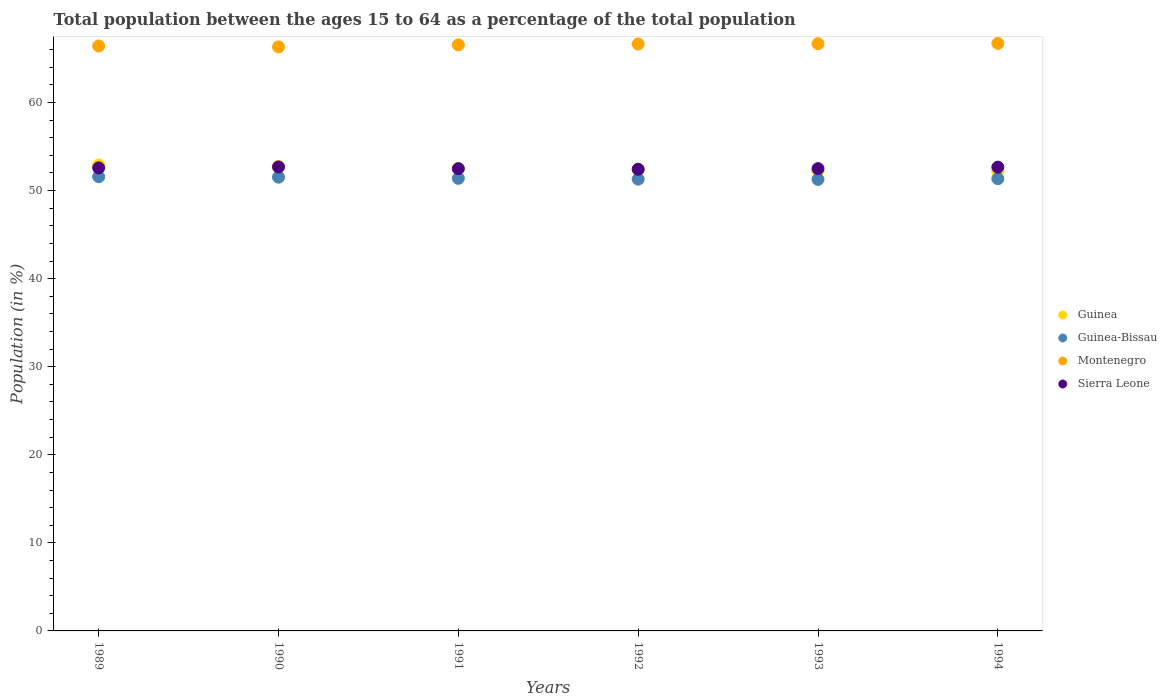How many different coloured dotlines are there?
Your response must be concise. 4. What is the percentage of the population ages 15 to 64 in Guinea in 1991?
Your answer should be very brief. 52.51. Across all years, what is the maximum percentage of the population ages 15 to 64 in Guinea-Bissau?
Give a very brief answer. 51.57. Across all years, what is the minimum percentage of the population ages 15 to 64 in Guinea-Bissau?
Offer a terse response. 51.27. In which year was the percentage of the population ages 15 to 64 in Sierra Leone minimum?
Ensure brevity in your answer.  1992. What is the total percentage of the population ages 15 to 64 in Guinea in the graph?
Offer a very short reply. 314.95. What is the difference between the percentage of the population ages 15 to 64 in Montenegro in 1991 and that in 1992?
Make the answer very short. -0.1. What is the difference between the percentage of the population ages 15 to 64 in Guinea-Bissau in 1991 and the percentage of the population ages 15 to 64 in Sierra Leone in 1990?
Ensure brevity in your answer.  -1.3. What is the average percentage of the population ages 15 to 64 in Sierra Leone per year?
Offer a very short reply. 52.55. In the year 1994, what is the difference between the percentage of the population ages 15 to 64 in Montenegro and percentage of the population ages 15 to 64 in Sierra Leone?
Provide a succinct answer. 14.05. What is the ratio of the percentage of the population ages 15 to 64 in Guinea in 1989 to that in 1994?
Provide a short and direct response. 1.01. What is the difference between the highest and the second highest percentage of the population ages 15 to 64 in Sierra Leone?
Your response must be concise. 0.02. What is the difference between the highest and the lowest percentage of the population ages 15 to 64 in Guinea-Bissau?
Your answer should be very brief. 0.3. Is the sum of the percentage of the population ages 15 to 64 in Guinea-Bissau in 1989 and 1991 greater than the maximum percentage of the population ages 15 to 64 in Sierra Leone across all years?
Provide a short and direct response. Yes. Is it the case that in every year, the sum of the percentage of the population ages 15 to 64 in Montenegro and percentage of the population ages 15 to 64 in Sierra Leone  is greater than the sum of percentage of the population ages 15 to 64 in Guinea-Bissau and percentage of the population ages 15 to 64 in Guinea?
Provide a succinct answer. Yes. Does the percentage of the population ages 15 to 64 in Montenegro monotonically increase over the years?
Offer a very short reply. No. Is the percentage of the population ages 15 to 64 in Guinea strictly greater than the percentage of the population ages 15 to 64 in Guinea-Bissau over the years?
Your response must be concise. Yes. How many dotlines are there?
Offer a very short reply. 4. Are the values on the major ticks of Y-axis written in scientific E-notation?
Make the answer very short. No. Does the graph contain any zero values?
Your answer should be compact. No. Where does the legend appear in the graph?
Your answer should be compact. Center right. How are the legend labels stacked?
Ensure brevity in your answer.  Vertical. What is the title of the graph?
Your answer should be compact. Total population between the ages 15 to 64 as a percentage of the total population. Does "Brunei Darussalam" appear as one of the legend labels in the graph?
Keep it short and to the point. No. What is the label or title of the X-axis?
Keep it short and to the point. Years. What is the Population (in %) of Guinea in 1989?
Provide a short and direct response. 52.91. What is the Population (in %) in Guinea-Bissau in 1989?
Give a very brief answer. 51.57. What is the Population (in %) in Montenegro in 1989?
Give a very brief answer. 66.42. What is the Population (in %) in Sierra Leone in 1989?
Give a very brief answer. 52.58. What is the Population (in %) in Guinea in 1990?
Keep it short and to the point. 52.74. What is the Population (in %) of Guinea-Bissau in 1990?
Offer a terse response. 51.52. What is the Population (in %) of Montenegro in 1990?
Give a very brief answer. 66.32. What is the Population (in %) in Sierra Leone in 1990?
Ensure brevity in your answer.  52.68. What is the Population (in %) of Guinea in 1991?
Offer a very short reply. 52.51. What is the Population (in %) in Guinea-Bissau in 1991?
Make the answer very short. 51.39. What is the Population (in %) of Montenegro in 1991?
Your answer should be very brief. 66.54. What is the Population (in %) in Sierra Leone in 1991?
Keep it short and to the point. 52.49. What is the Population (in %) of Guinea in 1992?
Keep it short and to the point. 52.35. What is the Population (in %) in Guinea-Bissau in 1992?
Provide a short and direct response. 51.3. What is the Population (in %) in Montenegro in 1992?
Your answer should be compact. 66.65. What is the Population (in %) of Sierra Leone in 1992?
Make the answer very short. 52.42. What is the Population (in %) in Guinea in 1993?
Offer a terse response. 52.24. What is the Population (in %) in Guinea-Bissau in 1993?
Provide a short and direct response. 51.27. What is the Population (in %) in Montenegro in 1993?
Make the answer very short. 66.68. What is the Population (in %) in Sierra Leone in 1993?
Provide a succinct answer. 52.49. What is the Population (in %) in Guinea in 1994?
Make the answer very short. 52.2. What is the Population (in %) in Guinea-Bissau in 1994?
Your answer should be compact. 51.35. What is the Population (in %) of Montenegro in 1994?
Make the answer very short. 66.71. What is the Population (in %) in Sierra Leone in 1994?
Provide a succinct answer. 52.66. Across all years, what is the maximum Population (in %) of Guinea?
Give a very brief answer. 52.91. Across all years, what is the maximum Population (in %) of Guinea-Bissau?
Give a very brief answer. 51.57. Across all years, what is the maximum Population (in %) in Montenegro?
Keep it short and to the point. 66.71. Across all years, what is the maximum Population (in %) of Sierra Leone?
Provide a succinct answer. 52.68. Across all years, what is the minimum Population (in %) of Guinea?
Offer a very short reply. 52.2. Across all years, what is the minimum Population (in %) of Guinea-Bissau?
Offer a terse response. 51.27. Across all years, what is the minimum Population (in %) in Montenegro?
Provide a succinct answer. 66.32. Across all years, what is the minimum Population (in %) in Sierra Leone?
Your answer should be very brief. 52.42. What is the total Population (in %) of Guinea in the graph?
Make the answer very short. 314.95. What is the total Population (in %) of Guinea-Bissau in the graph?
Keep it short and to the point. 308.39. What is the total Population (in %) in Montenegro in the graph?
Your answer should be compact. 399.31. What is the total Population (in %) of Sierra Leone in the graph?
Make the answer very short. 315.32. What is the difference between the Population (in %) in Guinea in 1989 and that in 1990?
Offer a very short reply. 0.17. What is the difference between the Population (in %) in Guinea-Bissau in 1989 and that in 1990?
Ensure brevity in your answer.  0.05. What is the difference between the Population (in %) in Sierra Leone in 1989 and that in 1990?
Offer a terse response. -0.11. What is the difference between the Population (in %) in Guinea in 1989 and that in 1991?
Your answer should be compact. 0.39. What is the difference between the Population (in %) in Guinea-Bissau in 1989 and that in 1991?
Make the answer very short. 0.18. What is the difference between the Population (in %) in Montenegro in 1989 and that in 1991?
Make the answer very short. -0.13. What is the difference between the Population (in %) of Sierra Leone in 1989 and that in 1991?
Ensure brevity in your answer.  0.09. What is the difference between the Population (in %) of Guinea in 1989 and that in 1992?
Offer a terse response. 0.55. What is the difference between the Population (in %) in Guinea-Bissau in 1989 and that in 1992?
Offer a terse response. 0.28. What is the difference between the Population (in %) of Montenegro in 1989 and that in 1992?
Provide a short and direct response. -0.23. What is the difference between the Population (in %) of Sierra Leone in 1989 and that in 1992?
Provide a short and direct response. 0.16. What is the difference between the Population (in %) in Guinea in 1989 and that in 1993?
Your response must be concise. 0.67. What is the difference between the Population (in %) of Guinea-Bissau in 1989 and that in 1993?
Keep it short and to the point. 0.3. What is the difference between the Population (in %) in Montenegro in 1989 and that in 1993?
Provide a short and direct response. -0.26. What is the difference between the Population (in %) in Sierra Leone in 1989 and that in 1993?
Ensure brevity in your answer.  0.09. What is the difference between the Population (in %) of Guinea in 1989 and that in 1994?
Ensure brevity in your answer.  0.71. What is the difference between the Population (in %) in Guinea-Bissau in 1989 and that in 1994?
Ensure brevity in your answer.  0.22. What is the difference between the Population (in %) of Montenegro in 1989 and that in 1994?
Your response must be concise. -0.3. What is the difference between the Population (in %) of Sierra Leone in 1989 and that in 1994?
Provide a short and direct response. -0.08. What is the difference between the Population (in %) of Guinea in 1990 and that in 1991?
Offer a terse response. 0.22. What is the difference between the Population (in %) in Guinea-Bissau in 1990 and that in 1991?
Your response must be concise. 0.13. What is the difference between the Population (in %) of Montenegro in 1990 and that in 1991?
Offer a terse response. -0.23. What is the difference between the Population (in %) of Sierra Leone in 1990 and that in 1991?
Your response must be concise. 0.2. What is the difference between the Population (in %) of Guinea in 1990 and that in 1992?
Offer a terse response. 0.39. What is the difference between the Population (in %) of Guinea-Bissau in 1990 and that in 1992?
Make the answer very short. 0.22. What is the difference between the Population (in %) in Montenegro in 1990 and that in 1992?
Your response must be concise. -0.33. What is the difference between the Population (in %) of Sierra Leone in 1990 and that in 1992?
Your answer should be compact. 0.26. What is the difference between the Population (in %) of Guinea in 1990 and that in 1993?
Your answer should be very brief. 0.5. What is the difference between the Population (in %) in Guinea-Bissau in 1990 and that in 1993?
Offer a terse response. 0.25. What is the difference between the Population (in %) of Montenegro in 1990 and that in 1993?
Your response must be concise. -0.36. What is the difference between the Population (in %) of Sierra Leone in 1990 and that in 1993?
Provide a short and direct response. 0.19. What is the difference between the Population (in %) in Guinea in 1990 and that in 1994?
Keep it short and to the point. 0.54. What is the difference between the Population (in %) in Guinea-Bissau in 1990 and that in 1994?
Make the answer very short. 0.17. What is the difference between the Population (in %) in Montenegro in 1990 and that in 1994?
Provide a succinct answer. -0.4. What is the difference between the Population (in %) in Sierra Leone in 1990 and that in 1994?
Offer a very short reply. 0.02. What is the difference between the Population (in %) of Guinea in 1991 and that in 1992?
Your response must be concise. 0.16. What is the difference between the Population (in %) of Guinea-Bissau in 1991 and that in 1992?
Keep it short and to the point. 0.09. What is the difference between the Population (in %) of Montenegro in 1991 and that in 1992?
Provide a short and direct response. -0.1. What is the difference between the Population (in %) in Sierra Leone in 1991 and that in 1992?
Offer a terse response. 0.07. What is the difference between the Population (in %) of Guinea in 1991 and that in 1993?
Your answer should be very brief. 0.28. What is the difference between the Population (in %) of Guinea-Bissau in 1991 and that in 1993?
Your answer should be compact. 0.12. What is the difference between the Population (in %) of Montenegro in 1991 and that in 1993?
Make the answer very short. -0.14. What is the difference between the Population (in %) of Sierra Leone in 1991 and that in 1993?
Offer a very short reply. -0.01. What is the difference between the Population (in %) in Guinea in 1991 and that in 1994?
Provide a succinct answer. 0.31. What is the difference between the Population (in %) in Guinea-Bissau in 1991 and that in 1994?
Offer a very short reply. 0.04. What is the difference between the Population (in %) of Montenegro in 1991 and that in 1994?
Ensure brevity in your answer.  -0.17. What is the difference between the Population (in %) of Sierra Leone in 1991 and that in 1994?
Your response must be concise. -0.17. What is the difference between the Population (in %) of Guinea in 1992 and that in 1993?
Provide a short and direct response. 0.12. What is the difference between the Population (in %) in Guinea-Bissau in 1992 and that in 1993?
Offer a terse response. 0.03. What is the difference between the Population (in %) in Montenegro in 1992 and that in 1993?
Keep it short and to the point. -0.03. What is the difference between the Population (in %) in Sierra Leone in 1992 and that in 1993?
Your answer should be very brief. -0.07. What is the difference between the Population (in %) in Guinea in 1992 and that in 1994?
Give a very brief answer. 0.15. What is the difference between the Population (in %) in Guinea-Bissau in 1992 and that in 1994?
Provide a short and direct response. -0.05. What is the difference between the Population (in %) of Montenegro in 1992 and that in 1994?
Provide a succinct answer. -0.07. What is the difference between the Population (in %) of Sierra Leone in 1992 and that in 1994?
Keep it short and to the point. -0.24. What is the difference between the Population (in %) in Guinea in 1993 and that in 1994?
Provide a succinct answer. 0.04. What is the difference between the Population (in %) of Guinea-Bissau in 1993 and that in 1994?
Make the answer very short. -0.08. What is the difference between the Population (in %) of Montenegro in 1993 and that in 1994?
Your answer should be compact. -0.03. What is the difference between the Population (in %) in Sierra Leone in 1993 and that in 1994?
Your answer should be compact. -0.17. What is the difference between the Population (in %) in Guinea in 1989 and the Population (in %) in Guinea-Bissau in 1990?
Give a very brief answer. 1.39. What is the difference between the Population (in %) in Guinea in 1989 and the Population (in %) in Montenegro in 1990?
Make the answer very short. -13.41. What is the difference between the Population (in %) of Guinea in 1989 and the Population (in %) of Sierra Leone in 1990?
Offer a very short reply. 0.22. What is the difference between the Population (in %) in Guinea-Bissau in 1989 and the Population (in %) in Montenegro in 1990?
Give a very brief answer. -14.74. What is the difference between the Population (in %) in Guinea-Bissau in 1989 and the Population (in %) in Sierra Leone in 1990?
Keep it short and to the point. -1.11. What is the difference between the Population (in %) in Montenegro in 1989 and the Population (in %) in Sierra Leone in 1990?
Give a very brief answer. 13.73. What is the difference between the Population (in %) in Guinea in 1989 and the Population (in %) in Guinea-Bissau in 1991?
Your answer should be compact. 1.52. What is the difference between the Population (in %) of Guinea in 1989 and the Population (in %) of Montenegro in 1991?
Offer a very short reply. -13.64. What is the difference between the Population (in %) in Guinea in 1989 and the Population (in %) in Sierra Leone in 1991?
Offer a very short reply. 0.42. What is the difference between the Population (in %) of Guinea-Bissau in 1989 and the Population (in %) of Montenegro in 1991?
Offer a terse response. -14.97. What is the difference between the Population (in %) of Guinea-Bissau in 1989 and the Population (in %) of Sierra Leone in 1991?
Your answer should be very brief. -0.91. What is the difference between the Population (in %) in Montenegro in 1989 and the Population (in %) in Sierra Leone in 1991?
Provide a succinct answer. 13.93. What is the difference between the Population (in %) in Guinea in 1989 and the Population (in %) in Guinea-Bissau in 1992?
Offer a very short reply. 1.61. What is the difference between the Population (in %) in Guinea in 1989 and the Population (in %) in Montenegro in 1992?
Your response must be concise. -13.74. What is the difference between the Population (in %) in Guinea in 1989 and the Population (in %) in Sierra Leone in 1992?
Offer a very short reply. 0.49. What is the difference between the Population (in %) of Guinea-Bissau in 1989 and the Population (in %) of Montenegro in 1992?
Offer a very short reply. -15.07. What is the difference between the Population (in %) in Guinea-Bissau in 1989 and the Population (in %) in Sierra Leone in 1992?
Offer a terse response. -0.85. What is the difference between the Population (in %) of Montenegro in 1989 and the Population (in %) of Sierra Leone in 1992?
Ensure brevity in your answer.  14. What is the difference between the Population (in %) in Guinea in 1989 and the Population (in %) in Guinea-Bissau in 1993?
Offer a very short reply. 1.64. What is the difference between the Population (in %) in Guinea in 1989 and the Population (in %) in Montenegro in 1993?
Provide a short and direct response. -13.77. What is the difference between the Population (in %) in Guinea in 1989 and the Population (in %) in Sierra Leone in 1993?
Give a very brief answer. 0.41. What is the difference between the Population (in %) of Guinea-Bissau in 1989 and the Population (in %) of Montenegro in 1993?
Your answer should be compact. -15.11. What is the difference between the Population (in %) in Guinea-Bissau in 1989 and the Population (in %) in Sierra Leone in 1993?
Offer a terse response. -0.92. What is the difference between the Population (in %) of Montenegro in 1989 and the Population (in %) of Sierra Leone in 1993?
Make the answer very short. 13.92. What is the difference between the Population (in %) in Guinea in 1989 and the Population (in %) in Guinea-Bissau in 1994?
Provide a succinct answer. 1.56. What is the difference between the Population (in %) of Guinea in 1989 and the Population (in %) of Montenegro in 1994?
Give a very brief answer. -13.81. What is the difference between the Population (in %) of Guinea in 1989 and the Population (in %) of Sierra Leone in 1994?
Provide a short and direct response. 0.25. What is the difference between the Population (in %) of Guinea-Bissau in 1989 and the Population (in %) of Montenegro in 1994?
Offer a very short reply. -15.14. What is the difference between the Population (in %) of Guinea-Bissau in 1989 and the Population (in %) of Sierra Leone in 1994?
Give a very brief answer. -1.09. What is the difference between the Population (in %) of Montenegro in 1989 and the Population (in %) of Sierra Leone in 1994?
Provide a succinct answer. 13.76. What is the difference between the Population (in %) in Guinea in 1990 and the Population (in %) in Guinea-Bissau in 1991?
Provide a short and direct response. 1.35. What is the difference between the Population (in %) of Guinea in 1990 and the Population (in %) of Montenegro in 1991?
Offer a terse response. -13.8. What is the difference between the Population (in %) of Guinea in 1990 and the Population (in %) of Sierra Leone in 1991?
Your response must be concise. 0.25. What is the difference between the Population (in %) of Guinea-Bissau in 1990 and the Population (in %) of Montenegro in 1991?
Provide a short and direct response. -15.02. What is the difference between the Population (in %) in Guinea-Bissau in 1990 and the Population (in %) in Sierra Leone in 1991?
Make the answer very short. -0.97. What is the difference between the Population (in %) in Montenegro in 1990 and the Population (in %) in Sierra Leone in 1991?
Offer a very short reply. 13.83. What is the difference between the Population (in %) of Guinea in 1990 and the Population (in %) of Guinea-Bissau in 1992?
Provide a short and direct response. 1.44. What is the difference between the Population (in %) of Guinea in 1990 and the Population (in %) of Montenegro in 1992?
Provide a short and direct response. -13.91. What is the difference between the Population (in %) in Guinea in 1990 and the Population (in %) in Sierra Leone in 1992?
Your answer should be compact. 0.32. What is the difference between the Population (in %) in Guinea-Bissau in 1990 and the Population (in %) in Montenegro in 1992?
Provide a short and direct response. -15.13. What is the difference between the Population (in %) of Guinea-Bissau in 1990 and the Population (in %) of Sierra Leone in 1992?
Give a very brief answer. -0.9. What is the difference between the Population (in %) in Montenegro in 1990 and the Population (in %) in Sierra Leone in 1992?
Your answer should be very brief. 13.9. What is the difference between the Population (in %) in Guinea in 1990 and the Population (in %) in Guinea-Bissau in 1993?
Your response must be concise. 1.47. What is the difference between the Population (in %) in Guinea in 1990 and the Population (in %) in Montenegro in 1993?
Make the answer very short. -13.94. What is the difference between the Population (in %) in Guinea in 1990 and the Population (in %) in Sierra Leone in 1993?
Your answer should be compact. 0.25. What is the difference between the Population (in %) of Guinea-Bissau in 1990 and the Population (in %) of Montenegro in 1993?
Your answer should be compact. -15.16. What is the difference between the Population (in %) of Guinea-Bissau in 1990 and the Population (in %) of Sierra Leone in 1993?
Give a very brief answer. -0.97. What is the difference between the Population (in %) of Montenegro in 1990 and the Population (in %) of Sierra Leone in 1993?
Offer a terse response. 13.82. What is the difference between the Population (in %) in Guinea in 1990 and the Population (in %) in Guinea-Bissau in 1994?
Provide a succinct answer. 1.39. What is the difference between the Population (in %) in Guinea in 1990 and the Population (in %) in Montenegro in 1994?
Make the answer very short. -13.98. What is the difference between the Population (in %) in Guinea in 1990 and the Population (in %) in Sierra Leone in 1994?
Your answer should be compact. 0.08. What is the difference between the Population (in %) in Guinea-Bissau in 1990 and the Population (in %) in Montenegro in 1994?
Provide a short and direct response. -15.19. What is the difference between the Population (in %) of Guinea-Bissau in 1990 and the Population (in %) of Sierra Leone in 1994?
Offer a terse response. -1.14. What is the difference between the Population (in %) of Montenegro in 1990 and the Population (in %) of Sierra Leone in 1994?
Keep it short and to the point. 13.66. What is the difference between the Population (in %) of Guinea in 1991 and the Population (in %) of Guinea-Bissau in 1992?
Your response must be concise. 1.22. What is the difference between the Population (in %) of Guinea in 1991 and the Population (in %) of Montenegro in 1992?
Offer a very short reply. -14.13. What is the difference between the Population (in %) in Guinea in 1991 and the Population (in %) in Sierra Leone in 1992?
Keep it short and to the point. 0.09. What is the difference between the Population (in %) in Guinea-Bissau in 1991 and the Population (in %) in Montenegro in 1992?
Make the answer very short. -15.26. What is the difference between the Population (in %) in Guinea-Bissau in 1991 and the Population (in %) in Sierra Leone in 1992?
Give a very brief answer. -1.03. What is the difference between the Population (in %) in Montenegro in 1991 and the Population (in %) in Sierra Leone in 1992?
Keep it short and to the point. 14.12. What is the difference between the Population (in %) in Guinea in 1991 and the Population (in %) in Guinea-Bissau in 1993?
Offer a very short reply. 1.24. What is the difference between the Population (in %) in Guinea in 1991 and the Population (in %) in Montenegro in 1993?
Offer a terse response. -14.17. What is the difference between the Population (in %) in Guinea in 1991 and the Population (in %) in Sierra Leone in 1993?
Make the answer very short. 0.02. What is the difference between the Population (in %) of Guinea-Bissau in 1991 and the Population (in %) of Montenegro in 1993?
Your answer should be very brief. -15.29. What is the difference between the Population (in %) of Guinea-Bissau in 1991 and the Population (in %) of Sierra Leone in 1993?
Ensure brevity in your answer.  -1.1. What is the difference between the Population (in %) of Montenegro in 1991 and the Population (in %) of Sierra Leone in 1993?
Offer a terse response. 14.05. What is the difference between the Population (in %) of Guinea in 1991 and the Population (in %) of Guinea-Bissau in 1994?
Make the answer very short. 1.17. What is the difference between the Population (in %) of Guinea in 1991 and the Population (in %) of Montenegro in 1994?
Give a very brief answer. -14.2. What is the difference between the Population (in %) in Guinea in 1991 and the Population (in %) in Sierra Leone in 1994?
Ensure brevity in your answer.  -0.15. What is the difference between the Population (in %) in Guinea-Bissau in 1991 and the Population (in %) in Montenegro in 1994?
Offer a terse response. -15.33. What is the difference between the Population (in %) in Guinea-Bissau in 1991 and the Population (in %) in Sierra Leone in 1994?
Your answer should be very brief. -1.27. What is the difference between the Population (in %) in Montenegro in 1991 and the Population (in %) in Sierra Leone in 1994?
Offer a very short reply. 13.88. What is the difference between the Population (in %) in Guinea in 1992 and the Population (in %) in Guinea-Bissau in 1993?
Ensure brevity in your answer.  1.08. What is the difference between the Population (in %) in Guinea in 1992 and the Population (in %) in Montenegro in 1993?
Offer a terse response. -14.33. What is the difference between the Population (in %) of Guinea in 1992 and the Population (in %) of Sierra Leone in 1993?
Ensure brevity in your answer.  -0.14. What is the difference between the Population (in %) in Guinea-Bissau in 1992 and the Population (in %) in Montenegro in 1993?
Keep it short and to the point. -15.38. What is the difference between the Population (in %) in Guinea-Bissau in 1992 and the Population (in %) in Sierra Leone in 1993?
Give a very brief answer. -1.2. What is the difference between the Population (in %) of Montenegro in 1992 and the Population (in %) of Sierra Leone in 1993?
Keep it short and to the point. 14.15. What is the difference between the Population (in %) in Guinea in 1992 and the Population (in %) in Montenegro in 1994?
Keep it short and to the point. -14.36. What is the difference between the Population (in %) of Guinea in 1992 and the Population (in %) of Sierra Leone in 1994?
Your answer should be compact. -0.31. What is the difference between the Population (in %) of Guinea-Bissau in 1992 and the Population (in %) of Montenegro in 1994?
Offer a terse response. -15.42. What is the difference between the Population (in %) in Guinea-Bissau in 1992 and the Population (in %) in Sierra Leone in 1994?
Your answer should be very brief. -1.36. What is the difference between the Population (in %) of Montenegro in 1992 and the Population (in %) of Sierra Leone in 1994?
Provide a short and direct response. 13.99. What is the difference between the Population (in %) of Guinea in 1993 and the Population (in %) of Guinea-Bissau in 1994?
Make the answer very short. 0.89. What is the difference between the Population (in %) of Guinea in 1993 and the Population (in %) of Montenegro in 1994?
Keep it short and to the point. -14.48. What is the difference between the Population (in %) of Guinea in 1993 and the Population (in %) of Sierra Leone in 1994?
Your response must be concise. -0.42. What is the difference between the Population (in %) in Guinea-Bissau in 1993 and the Population (in %) in Montenegro in 1994?
Give a very brief answer. -15.44. What is the difference between the Population (in %) of Guinea-Bissau in 1993 and the Population (in %) of Sierra Leone in 1994?
Ensure brevity in your answer.  -1.39. What is the difference between the Population (in %) in Montenegro in 1993 and the Population (in %) in Sierra Leone in 1994?
Ensure brevity in your answer.  14.02. What is the average Population (in %) in Guinea per year?
Ensure brevity in your answer.  52.49. What is the average Population (in %) of Guinea-Bissau per year?
Your response must be concise. 51.4. What is the average Population (in %) in Montenegro per year?
Your answer should be very brief. 66.55. What is the average Population (in %) in Sierra Leone per year?
Make the answer very short. 52.55. In the year 1989, what is the difference between the Population (in %) in Guinea and Population (in %) in Guinea-Bissau?
Your answer should be very brief. 1.33. In the year 1989, what is the difference between the Population (in %) in Guinea and Population (in %) in Montenegro?
Provide a short and direct response. -13.51. In the year 1989, what is the difference between the Population (in %) of Guinea and Population (in %) of Sierra Leone?
Your response must be concise. 0.33. In the year 1989, what is the difference between the Population (in %) in Guinea-Bissau and Population (in %) in Montenegro?
Make the answer very short. -14.85. In the year 1989, what is the difference between the Population (in %) in Guinea-Bissau and Population (in %) in Sierra Leone?
Provide a succinct answer. -1.01. In the year 1989, what is the difference between the Population (in %) of Montenegro and Population (in %) of Sierra Leone?
Provide a succinct answer. 13.84. In the year 1990, what is the difference between the Population (in %) of Guinea and Population (in %) of Guinea-Bissau?
Your answer should be very brief. 1.22. In the year 1990, what is the difference between the Population (in %) in Guinea and Population (in %) in Montenegro?
Provide a short and direct response. -13.58. In the year 1990, what is the difference between the Population (in %) in Guinea and Population (in %) in Sierra Leone?
Offer a terse response. 0.05. In the year 1990, what is the difference between the Population (in %) in Guinea-Bissau and Population (in %) in Montenegro?
Your response must be concise. -14.8. In the year 1990, what is the difference between the Population (in %) in Guinea-Bissau and Population (in %) in Sierra Leone?
Keep it short and to the point. -1.16. In the year 1990, what is the difference between the Population (in %) in Montenegro and Population (in %) in Sierra Leone?
Provide a succinct answer. 13.63. In the year 1991, what is the difference between the Population (in %) in Guinea and Population (in %) in Guinea-Bissau?
Offer a very short reply. 1.13. In the year 1991, what is the difference between the Population (in %) of Guinea and Population (in %) of Montenegro?
Give a very brief answer. -14.03. In the year 1991, what is the difference between the Population (in %) of Guinea and Population (in %) of Sierra Leone?
Ensure brevity in your answer.  0.03. In the year 1991, what is the difference between the Population (in %) of Guinea-Bissau and Population (in %) of Montenegro?
Provide a succinct answer. -15.16. In the year 1991, what is the difference between the Population (in %) in Guinea-Bissau and Population (in %) in Sierra Leone?
Offer a very short reply. -1.1. In the year 1991, what is the difference between the Population (in %) of Montenegro and Population (in %) of Sierra Leone?
Give a very brief answer. 14.06. In the year 1992, what is the difference between the Population (in %) in Guinea and Population (in %) in Guinea-Bissau?
Keep it short and to the point. 1.06. In the year 1992, what is the difference between the Population (in %) in Guinea and Population (in %) in Montenegro?
Give a very brief answer. -14.29. In the year 1992, what is the difference between the Population (in %) of Guinea and Population (in %) of Sierra Leone?
Keep it short and to the point. -0.07. In the year 1992, what is the difference between the Population (in %) in Guinea-Bissau and Population (in %) in Montenegro?
Offer a terse response. -15.35. In the year 1992, what is the difference between the Population (in %) of Guinea-Bissau and Population (in %) of Sierra Leone?
Ensure brevity in your answer.  -1.12. In the year 1992, what is the difference between the Population (in %) in Montenegro and Population (in %) in Sierra Leone?
Your response must be concise. 14.23. In the year 1993, what is the difference between the Population (in %) of Guinea and Population (in %) of Montenegro?
Your answer should be compact. -14.44. In the year 1993, what is the difference between the Population (in %) in Guinea and Population (in %) in Sierra Leone?
Your answer should be very brief. -0.25. In the year 1993, what is the difference between the Population (in %) of Guinea-Bissau and Population (in %) of Montenegro?
Offer a terse response. -15.41. In the year 1993, what is the difference between the Population (in %) of Guinea-Bissau and Population (in %) of Sierra Leone?
Keep it short and to the point. -1.22. In the year 1993, what is the difference between the Population (in %) of Montenegro and Population (in %) of Sierra Leone?
Your answer should be compact. 14.19. In the year 1994, what is the difference between the Population (in %) of Guinea and Population (in %) of Guinea-Bissau?
Keep it short and to the point. 0.85. In the year 1994, what is the difference between the Population (in %) of Guinea and Population (in %) of Montenegro?
Provide a succinct answer. -14.51. In the year 1994, what is the difference between the Population (in %) of Guinea and Population (in %) of Sierra Leone?
Ensure brevity in your answer.  -0.46. In the year 1994, what is the difference between the Population (in %) in Guinea-Bissau and Population (in %) in Montenegro?
Your response must be concise. -15.37. In the year 1994, what is the difference between the Population (in %) in Guinea-Bissau and Population (in %) in Sierra Leone?
Provide a short and direct response. -1.31. In the year 1994, what is the difference between the Population (in %) of Montenegro and Population (in %) of Sierra Leone?
Offer a terse response. 14.05. What is the ratio of the Population (in %) in Guinea in 1989 to that in 1990?
Your answer should be very brief. 1. What is the ratio of the Population (in %) of Montenegro in 1989 to that in 1990?
Offer a very short reply. 1. What is the ratio of the Population (in %) of Guinea in 1989 to that in 1991?
Ensure brevity in your answer.  1.01. What is the ratio of the Population (in %) in Guinea-Bissau in 1989 to that in 1991?
Your answer should be compact. 1. What is the ratio of the Population (in %) of Montenegro in 1989 to that in 1991?
Ensure brevity in your answer.  1. What is the ratio of the Population (in %) of Sierra Leone in 1989 to that in 1991?
Provide a short and direct response. 1. What is the ratio of the Population (in %) in Guinea in 1989 to that in 1992?
Make the answer very short. 1.01. What is the ratio of the Population (in %) of Guinea-Bissau in 1989 to that in 1992?
Your response must be concise. 1.01. What is the ratio of the Population (in %) of Montenegro in 1989 to that in 1992?
Your response must be concise. 1. What is the ratio of the Population (in %) of Sierra Leone in 1989 to that in 1992?
Ensure brevity in your answer.  1. What is the ratio of the Population (in %) in Guinea in 1989 to that in 1993?
Keep it short and to the point. 1.01. What is the ratio of the Population (in %) of Guinea-Bissau in 1989 to that in 1993?
Provide a succinct answer. 1.01. What is the ratio of the Population (in %) in Guinea in 1989 to that in 1994?
Your answer should be compact. 1.01. What is the ratio of the Population (in %) of Montenegro in 1989 to that in 1994?
Provide a short and direct response. 1. What is the ratio of the Population (in %) of Sierra Leone in 1989 to that in 1994?
Your answer should be very brief. 1. What is the ratio of the Population (in %) of Montenegro in 1990 to that in 1991?
Keep it short and to the point. 1. What is the ratio of the Population (in %) of Sierra Leone in 1990 to that in 1991?
Your answer should be compact. 1. What is the ratio of the Population (in %) in Guinea in 1990 to that in 1992?
Give a very brief answer. 1.01. What is the ratio of the Population (in %) of Sierra Leone in 1990 to that in 1992?
Keep it short and to the point. 1. What is the ratio of the Population (in %) of Guinea in 1990 to that in 1993?
Make the answer very short. 1.01. What is the ratio of the Population (in %) of Sierra Leone in 1990 to that in 1993?
Your answer should be very brief. 1. What is the ratio of the Population (in %) in Guinea in 1990 to that in 1994?
Your answer should be compact. 1.01. What is the ratio of the Population (in %) of Guinea-Bissau in 1990 to that in 1994?
Your response must be concise. 1. What is the ratio of the Population (in %) in Montenegro in 1990 to that in 1994?
Your response must be concise. 0.99. What is the ratio of the Population (in %) of Guinea-Bissau in 1991 to that in 1992?
Provide a succinct answer. 1. What is the ratio of the Population (in %) of Guinea in 1991 to that in 1993?
Give a very brief answer. 1.01. What is the ratio of the Population (in %) of Guinea in 1991 to that in 1994?
Provide a succinct answer. 1.01. What is the ratio of the Population (in %) of Sierra Leone in 1991 to that in 1994?
Your answer should be very brief. 1. What is the ratio of the Population (in %) in Guinea in 1992 to that in 1993?
Your answer should be compact. 1. What is the ratio of the Population (in %) of Guinea-Bissau in 1992 to that in 1993?
Give a very brief answer. 1. What is the ratio of the Population (in %) in Montenegro in 1992 to that in 1993?
Ensure brevity in your answer.  1. What is the ratio of the Population (in %) of Sierra Leone in 1992 to that in 1993?
Offer a terse response. 1. What is the ratio of the Population (in %) in Guinea in 1992 to that in 1994?
Give a very brief answer. 1. What is the ratio of the Population (in %) in Sierra Leone in 1992 to that in 1994?
Give a very brief answer. 1. What is the ratio of the Population (in %) in Guinea-Bissau in 1993 to that in 1994?
Your response must be concise. 1. What is the ratio of the Population (in %) of Montenegro in 1993 to that in 1994?
Keep it short and to the point. 1. What is the difference between the highest and the second highest Population (in %) in Guinea?
Provide a succinct answer. 0.17. What is the difference between the highest and the second highest Population (in %) of Guinea-Bissau?
Your answer should be compact. 0.05. What is the difference between the highest and the second highest Population (in %) of Montenegro?
Provide a short and direct response. 0.03. What is the difference between the highest and the second highest Population (in %) in Sierra Leone?
Your answer should be compact. 0.02. What is the difference between the highest and the lowest Population (in %) in Guinea?
Provide a short and direct response. 0.71. What is the difference between the highest and the lowest Population (in %) in Guinea-Bissau?
Keep it short and to the point. 0.3. What is the difference between the highest and the lowest Population (in %) of Montenegro?
Your response must be concise. 0.4. What is the difference between the highest and the lowest Population (in %) of Sierra Leone?
Make the answer very short. 0.26. 